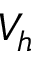<formula> <loc_0><loc_0><loc_500><loc_500>V _ { h }</formula> 